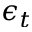Convert formula to latex. <formula><loc_0><loc_0><loc_500><loc_500>\epsilon _ { t }</formula> 